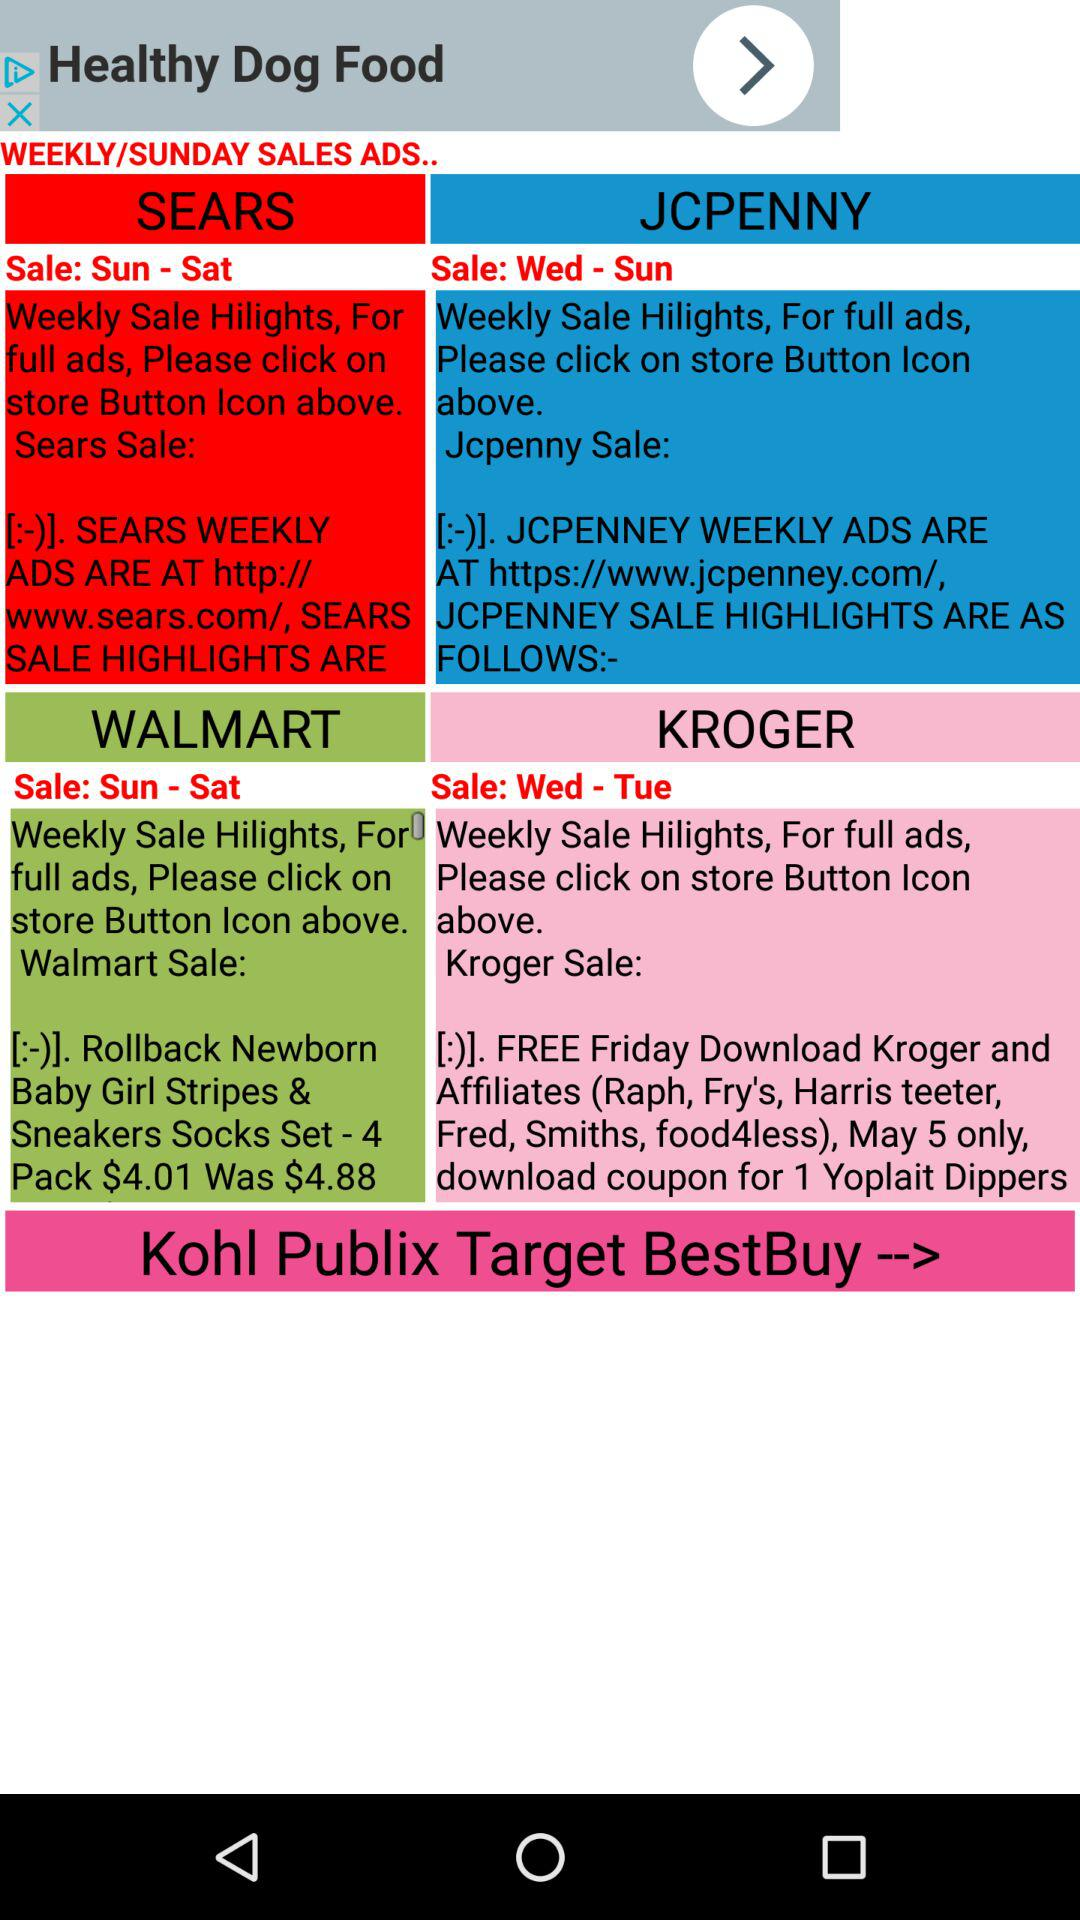What is the sale day for "KROGER"? The sale days are from Wednesday to Tuesday. 